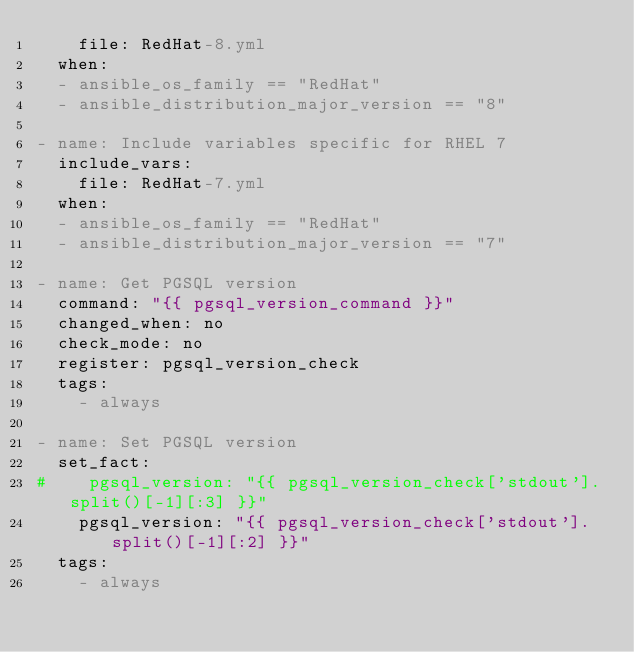<code> <loc_0><loc_0><loc_500><loc_500><_YAML_>    file: RedHat-8.yml
  when:
  - ansible_os_family == "RedHat"
  - ansible_distribution_major_version == "8"

- name: Include variables specific for RHEL 7
  include_vars:
    file: RedHat-7.yml
  when:
  - ansible_os_family == "RedHat"
  - ansible_distribution_major_version == "7"

- name: Get PGSQL version
  command: "{{ pgsql_version_command }}"
  changed_when: no
  check_mode: no
  register: pgsql_version_check
  tags:
    - always

- name: Set PGSQL version
  set_fact:
#    pgsql_version: "{{ pgsql_version_check['stdout'].split()[-1][:3] }}"
    pgsql_version: "{{ pgsql_version_check['stdout'].split()[-1][:2] }}"
  tags:
    - always
</code> 